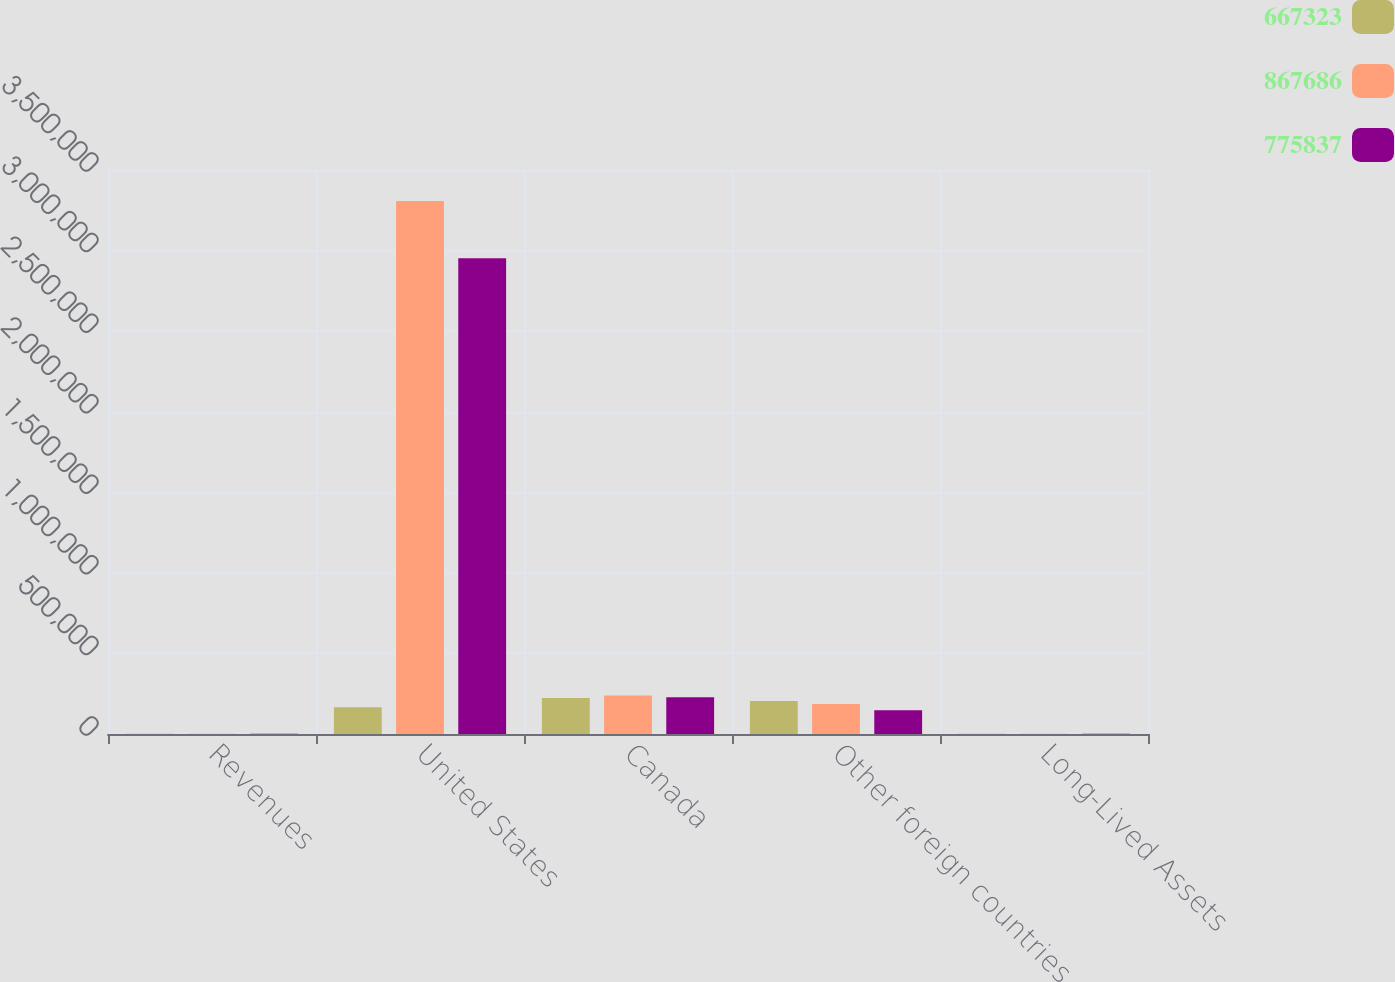Convert chart to OTSL. <chart><loc_0><loc_0><loc_500><loc_500><stacked_bar_chart><ecel><fcel>Revenues<fcel>United States<fcel>Canada<fcel>Other foreign countries<fcel>Long-Lived Assets<nl><fcel>667323<fcel>2015<fcel>166684<fcel>223270<fcel>204776<fcel>2015<nl><fcel>867686<fcel>2014<fcel>3.30823e+06<fcel>238590<fcel>186691<fcel>2014<nl><fcel>775837<fcel>2013<fcel>2.95167e+06<fcel>227756<fcel>146677<fcel>2013<nl></chart> 